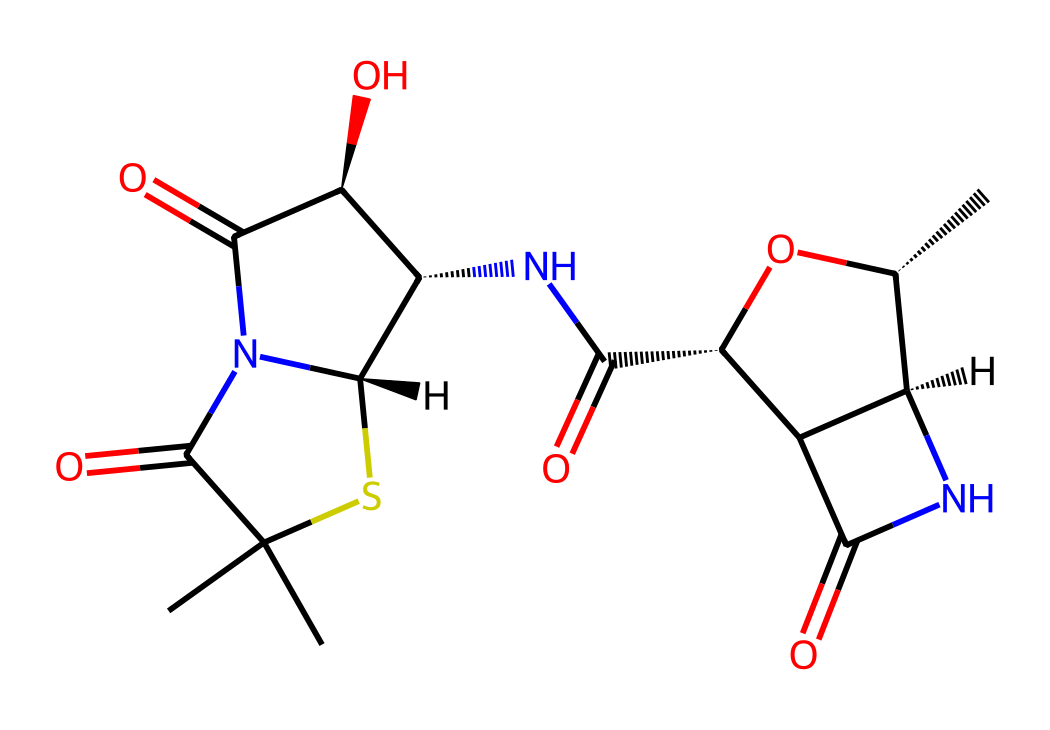What is the molecular formula of Penicillin? To determine the molecular formula, identify the number of each type of atom present in the structure. Analyzing the SMILES indicates there are 16 carbons (C), 19 hydrogens (H), 4 nitrogens (N), 6 oxygens (O), and 1 sulfur (S). Thus, the molecular formula is C16H19N4O6S.
Answer: C16H19N4O6S How many nitrogen atoms are present in the structure? To find the number of nitrogen atoms, closely examine the SMILES representation and count the "N" symbols. There are 4 distinct "N" symbols in the structure, indicating there are 4 nitrogen atoms.
Answer: 4 What is the significance of the sulfur atom in Penicillin? Penicillin's sulfur atom is essential as it contributes to the thiazolidine ring, which is crucial for its biological activity, playing a role in the antibiotic properties of the molecule.
Answer: biological activity Which functional group is present in Penicillin? By examining the chemical structure, we can see that Penicillin contains a beta-lactam ring structure, which is a defining functional group characteristic of its antibiotic properties.
Answer: beta-lactam What type of bond connects the carbon atoms in Penicillin? The carbon atoms are primarily connected by single (sigma) and double bonds as indicated in the SMILES notation, showing a combination of both types of bonds in the overall structure.
Answer: single and double bonds Where is the carboxylic acid group located in Penicillin? In the SMILES representation, the carboxylic acid group is indicated by "C(=O)O." This confirms that the carboxylic acid is located within the main structure. Analyzing the structure leads to identifying that it is situated near the nitrogen atoms in the ring.
Answer: near the nitrogen atoms 